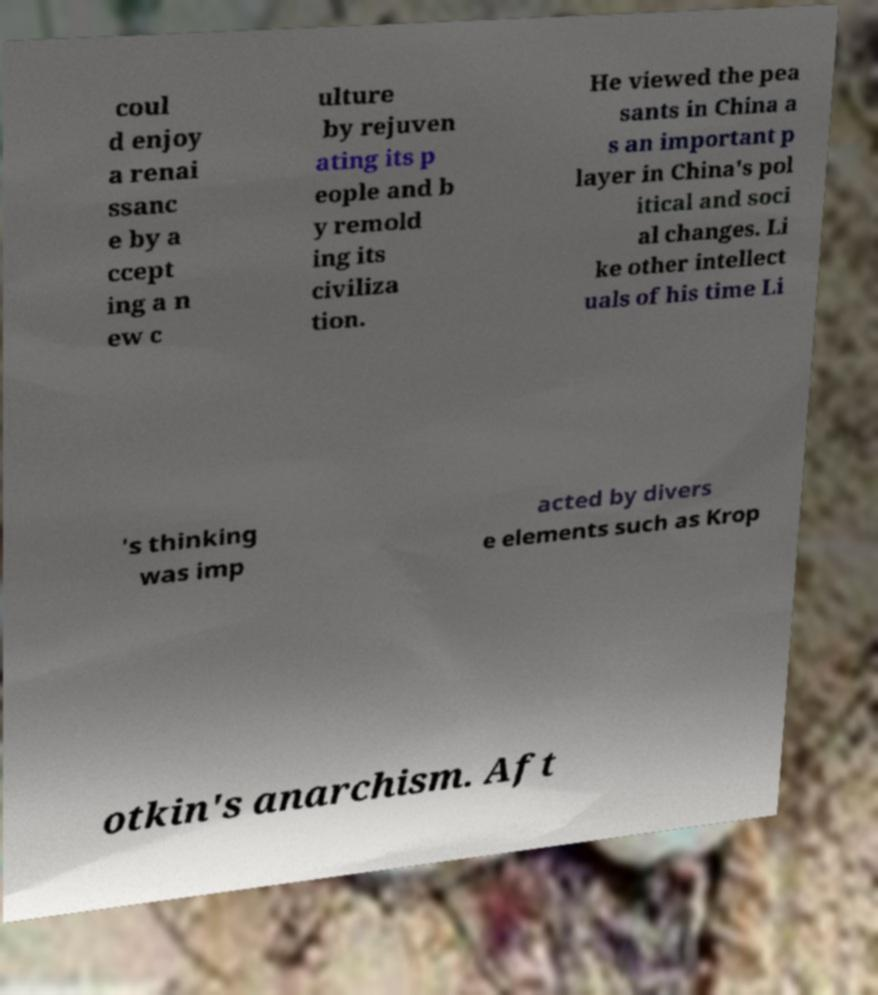For documentation purposes, I need the text within this image transcribed. Could you provide that? coul d enjoy a renai ssanc e by a ccept ing a n ew c ulture by rejuven ating its p eople and b y remold ing its civiliza tion. He viewed the pea sants in China a s an important p layer in China's pol itical and soci al changes. Li ke other intellect uals of his time Li 's thinking was imp acted by divers e elements such as Krop otkin's anarchism. Aft 